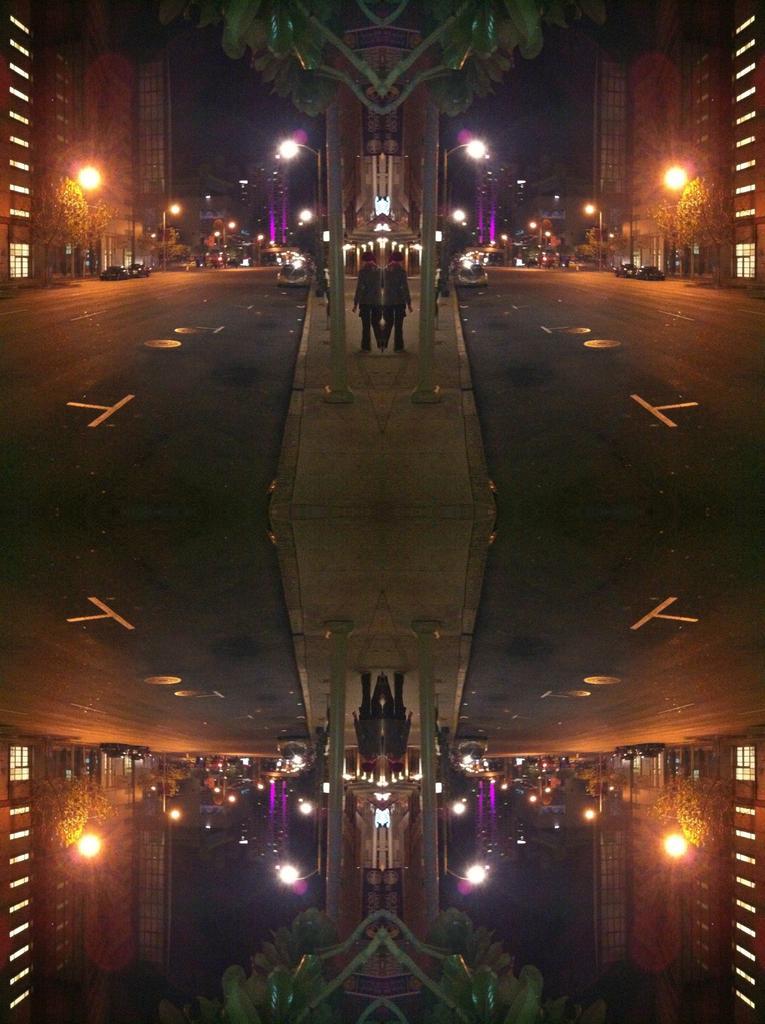Can you describe this image briefly? Here we can see an edited image which is a mirror reflection. Here we can see lights, poles, persons, road, and buildings. There are trees. 